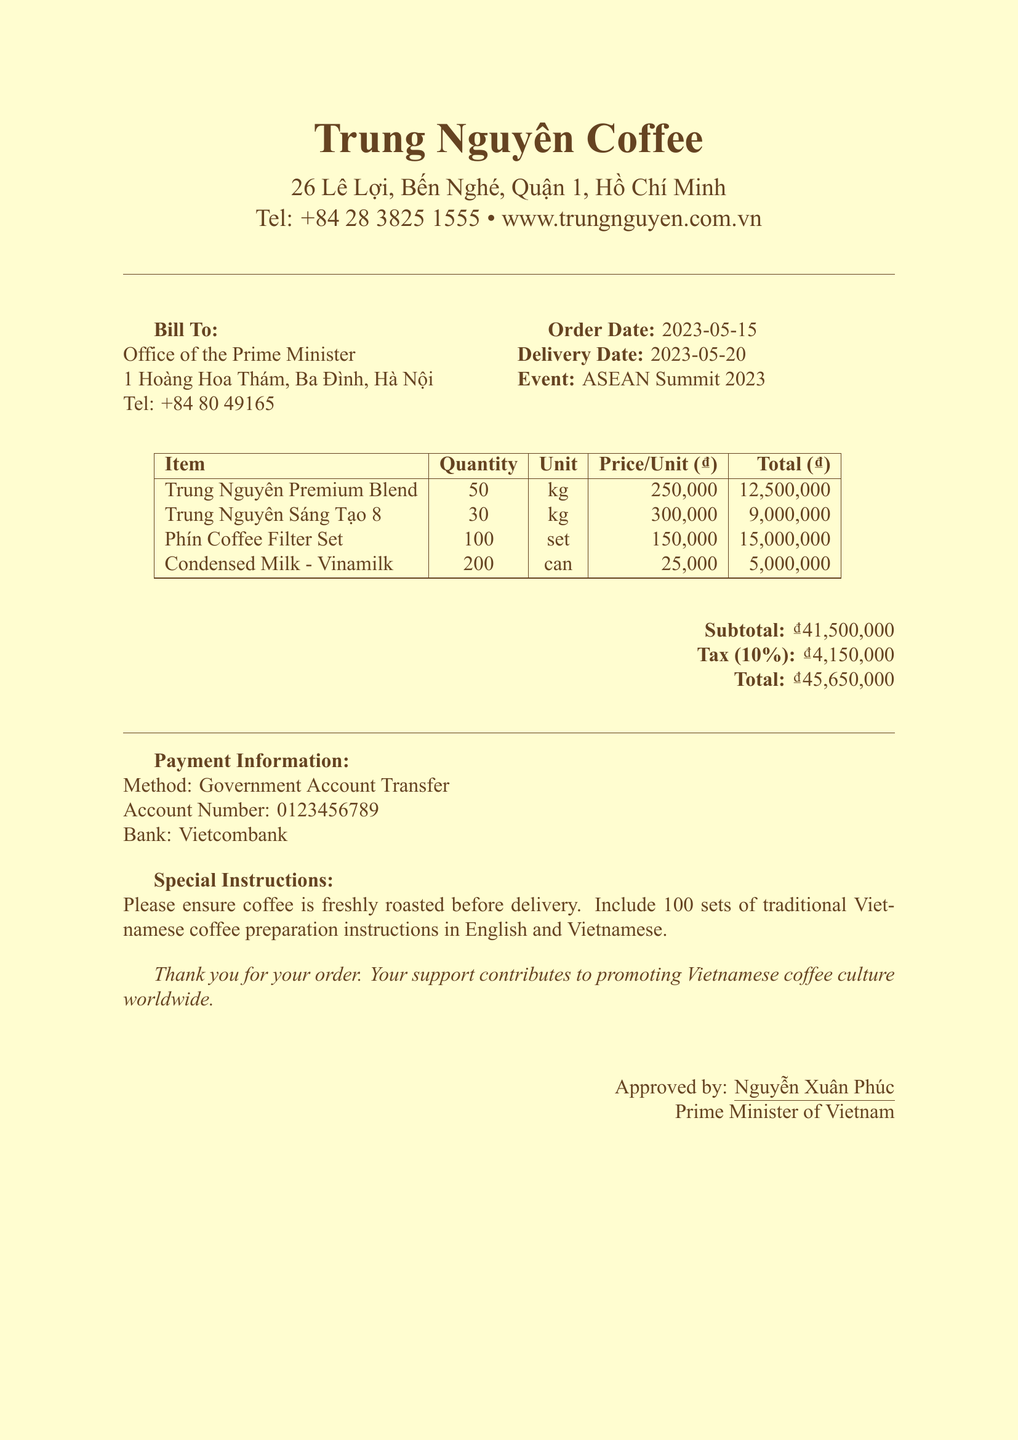What is the name of the company on the receipt? The company name listed in the receipt header is Trung Nguyên Coffee.
Answer: Trung Nguyên Coffee What is the total amount due? The total amount is provided in the payment information section of the receipt.
Answer: ₫45,650,000 How many kilograms of Trung Nguyên Sáng Tạo 8 were ordered? The quantity of Trung Nguyên Sáng Tạo 8 is specified in the order details section.
Answer: 30 kg What is the delivery date for this order? The delivery date is mentioned in the additional info section of the receipt.
Answer: 2023-05-20 What payment method is used for this transaction? The payment method is specified in the payment information section of the receipt.
Answer: Government Account Transfer What is the subtotal before tax? The subtotal is highlighted in the payment information section of the receipt.
Answer: ₫41,500,000 Who approved the order? The approval is noted at the end of the receipt, listing the person in charge.
Answer: Nguyễn Xuân Phúc What special instructions were provided for the order? The special instructions can be found in the additional information section of the receipt.
Answer: Please ensure coffee is freshly roasted before delivery. Include 100 sets of traditional Vietnamese coffee preparation instructions in English and Vietnamese 